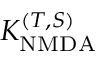Convert formula to latex. <formula><loc_0><loc_0><loc_500><loc_500>K _ { N M D A } ^ { ( T , S ) }</formula> 